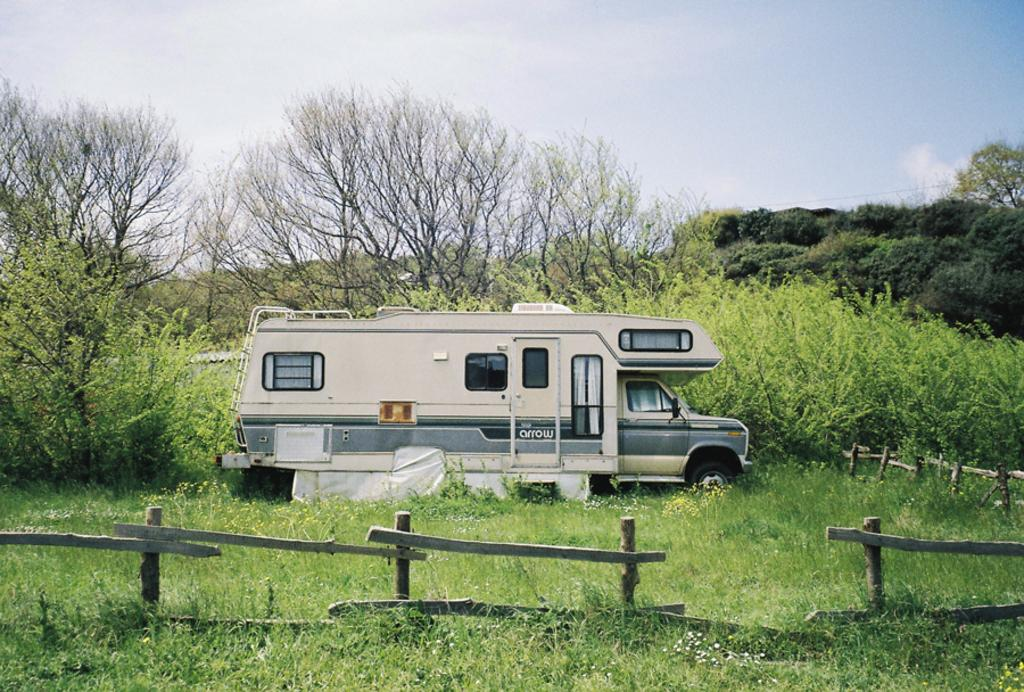What is the main subject in the center of the image? There is a truck in the center of the image. What is the position of the truck in relation to the ground? The truck is on the ground. What type of vegetation can be seen in the image? There is grass, plants with flowers, and a group of trees visible in the image. What is the condition of the sky in the image? The sky is visible in the image and appears cloudy. What type of fence can be seen in the image? There is a wooden fence in the image. How many servants are visible in the image? There are no servants present in the image. What type of pocket can be seen on the truck in the image? There is no pocket visible on the truck in the image. 